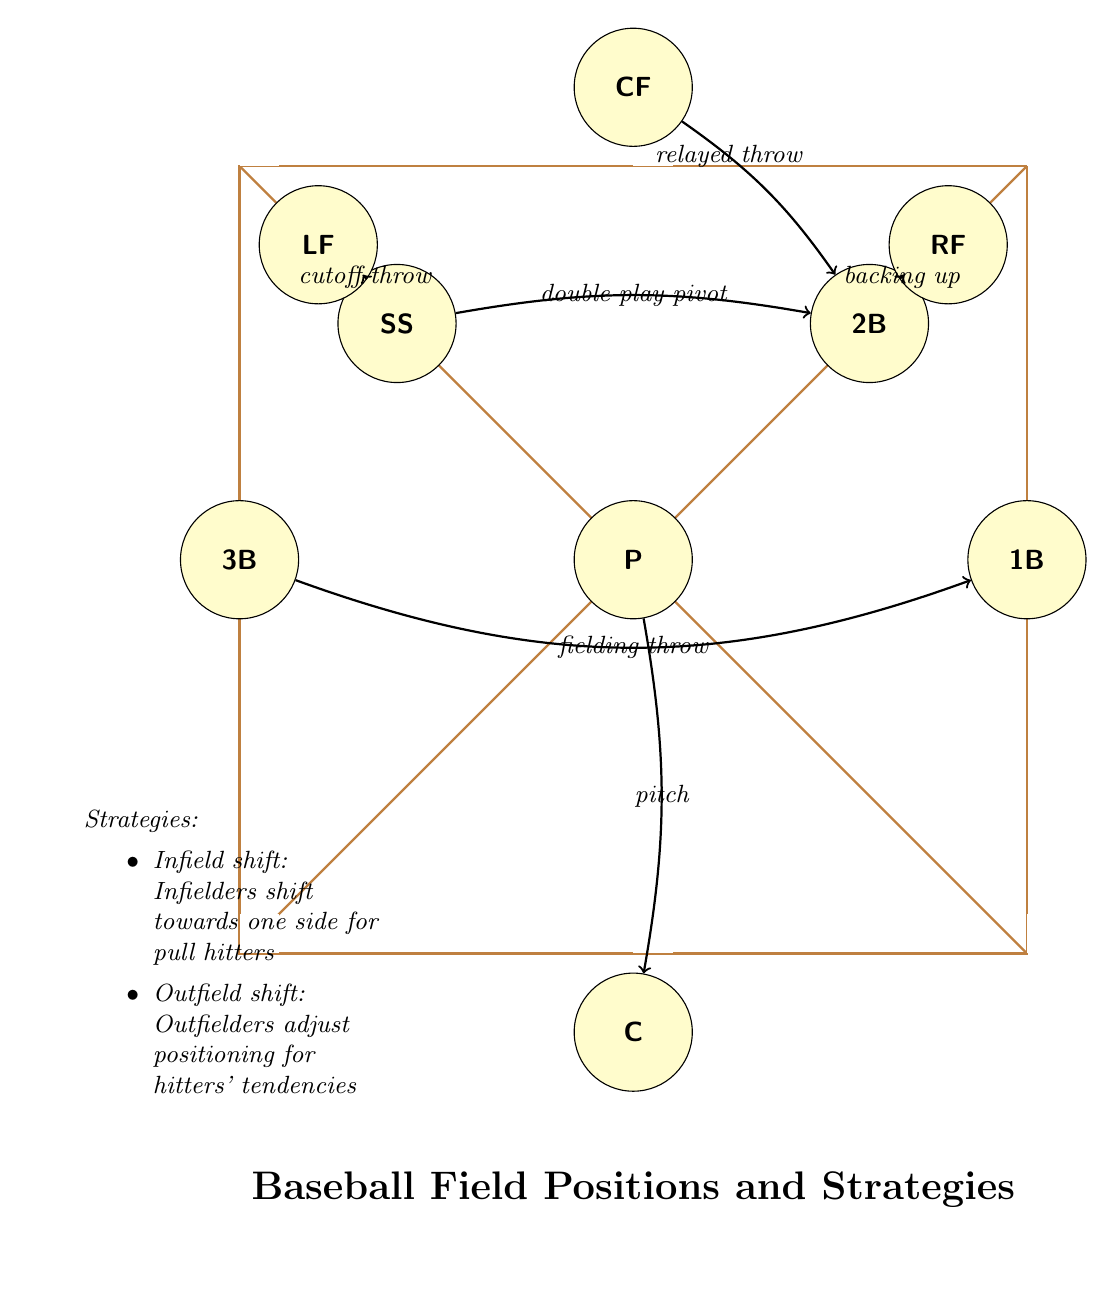What positions are represented on the diagram? The diagram clearly labels positions: Pitcher, Catcher, First Base, Second Base, Shortstop, Third Base, Left Field, Center Field, Right Field. These are all the player positions visible in the diagram.
Answer: Pitcher, Catcher, First Base, Second Base, Shortstop, Third Base, Left Field, Center Field, Right Field How many players are in the infield? The infield consists of the positions: First Base, Second Base, Shortstop, and Third Base. By counting these labels in the diagram, we find there are four infield positions.
Answer: 4 What is the role of the Shortstop in a double play? The diagram indicates that the Shortstop has the role of pivot in a double play, suggesting it is a central position for executing this strategy.
Answer: double play pivot Which fielding strategy involves outfielders adjusting positions? The diagram mentions an "Outfield shift" strategy, which specifically focuses on outfielders adapting their positioning based on hitters’ tendencies.
Answer: Outfield shift What is the purpose of the cutoff throw illustrated by the Left Field? The diagram defines the Left Field’s role in "cutoff throw," which involves fielding the ball and strategically directing it to another position, typically to prevent extra bases.
Answer: cutoff throw How does the Catcher interact with the Pitcher? The relationship indicated in the diagram shows that the Catcher is set to receive a pitch from the Pitcher, indicating their direct connection during the game.
Answer: pitch What is indicated by the connection between Second Base and the Shortstop? The diagram shows an edge between Shortstop and Second Base labeled as "double play pivot," indicating a crucial role in executing double plays, where the Shortstop can transition the ball to Second Base efficiently.
Answer: double play pivot What does the diagram suggest about infield shifts? The diagram includes a note about "Infield shift," explaining that this strategy involves infielders shifting towards one side in response to pull hitters, which showcases a tactic for enhancing defensive strength.
Answer: Infield shift How many edges are shown in the diagram? By observing the connections illustrated between various player positions, counting reveals a total of six edges present in the diagram.
Answer: 6 